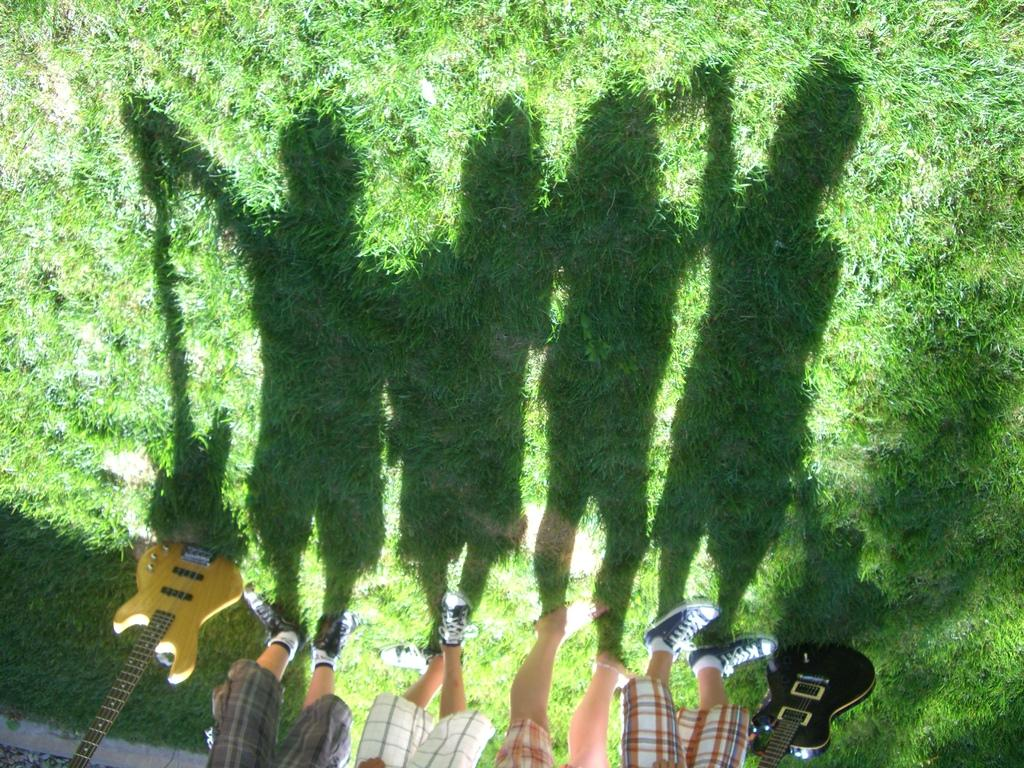How many people are standing in the image? There are four people standing in the image. What objects are visible in the image besides the people? There are two guitars visible in the image. Can you describe the shadow in the image? The shadow of the four people standing is visible in the image. What type of ground is present in the image? There is grass in the image. What type of popcorn is being served to the daughter in the image? There is no daughter or popcorn present in the image. 